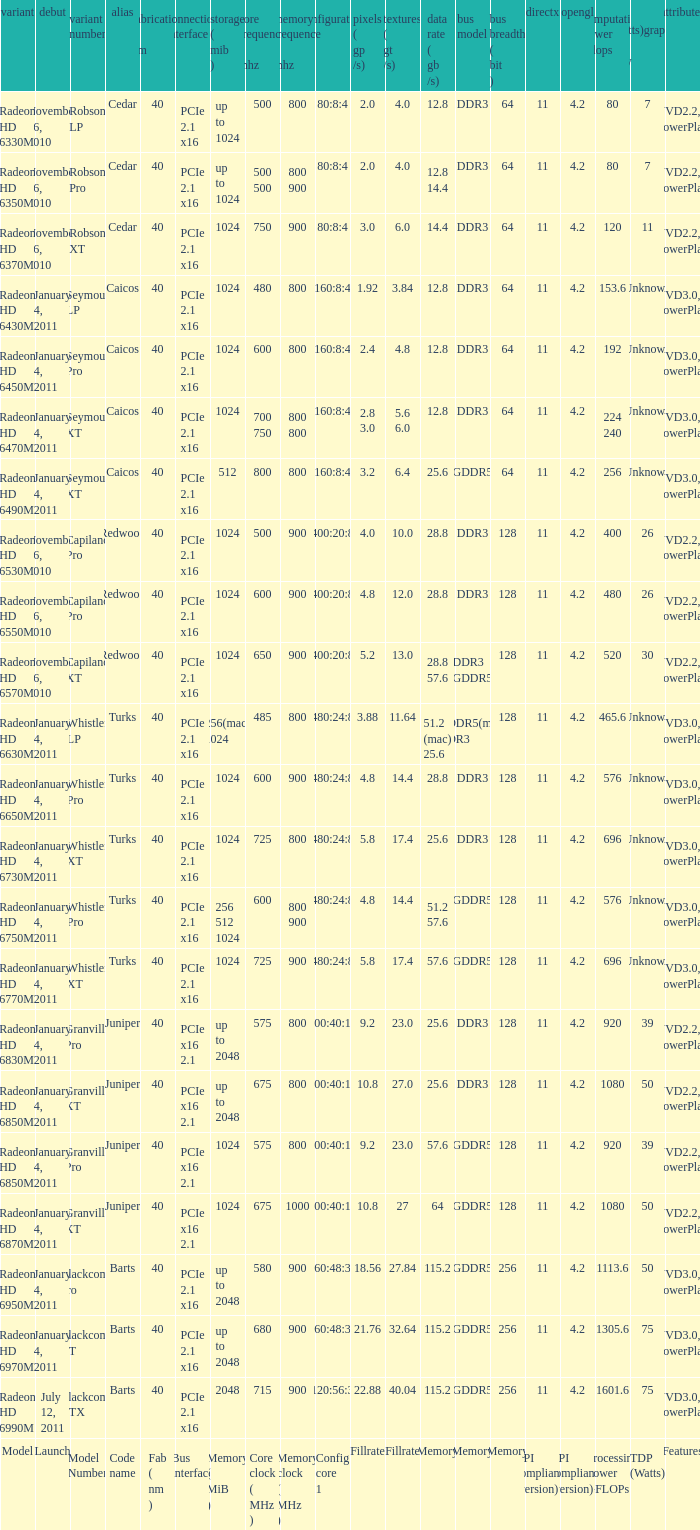What is the value for congi core 1 if the code name is Redwood and core clock(mhz) is 500? 400:20:8. 